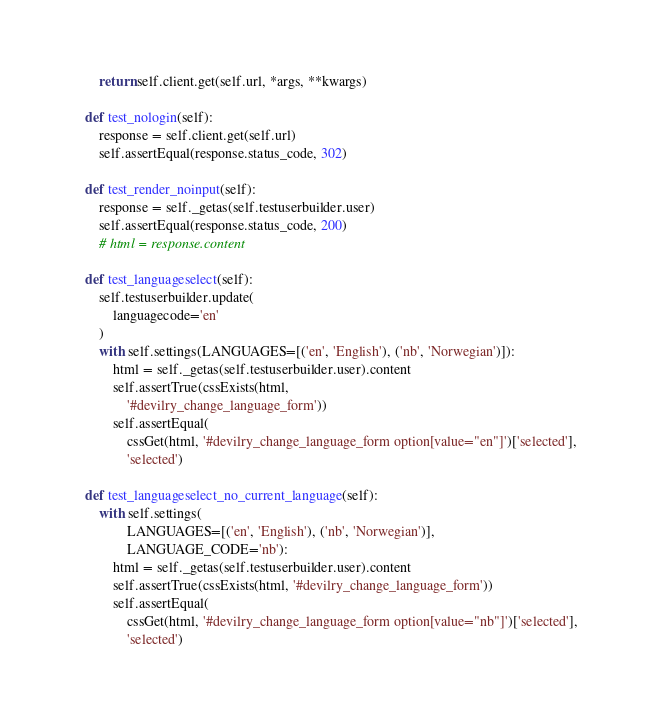Convert code to text. <code><loc_0><loc_0><loc_500><loc_500><_Python_>        return self.client.get(self.url, *args, **kwargs)

    def test_nologin(self):
        response = self.client.get(self.url)
        self.assertEqual(response.status_code, 302)

    def test_render_noinput(self):
        response = self._getas(self.testuserbuilder.user)
        self.assertEqual(response.status_code, 200)
        # html = response.content

    def test_languageselect(self):
        self.testuserbuilder.update(
            languagecode='en'
        )
        with self.settings(LANGUAGES=[('en', 'English'), ('nb', 'Norwegian')]):
            html = self._getas(self.testuserbuilder.user).content
            self.assertTrue(cssExists(html,
                '#devilry_change_language_form'))
            self.assertEqual(
                cssGet(html, '#devilry_change_language_form option[value="en"]')['selected'],
                'selected')

    def test_languageselect_no_current_language(self):
        with self.settings(
                LANGUAGES=[('en', 'English'), ('nb', 'Norwegian')],
                LANGUAGE_CODE='nb'):
            html = self._getas(self.testuserbuilder.user).content
            self.assertTrue(cssExists(html, '#devilry_change_language_form'))
            self.assertEqual(
                cssGet(html, '#devilry_change_language_form option[value="nb"]')['selected'],
                'selected')
</code> 